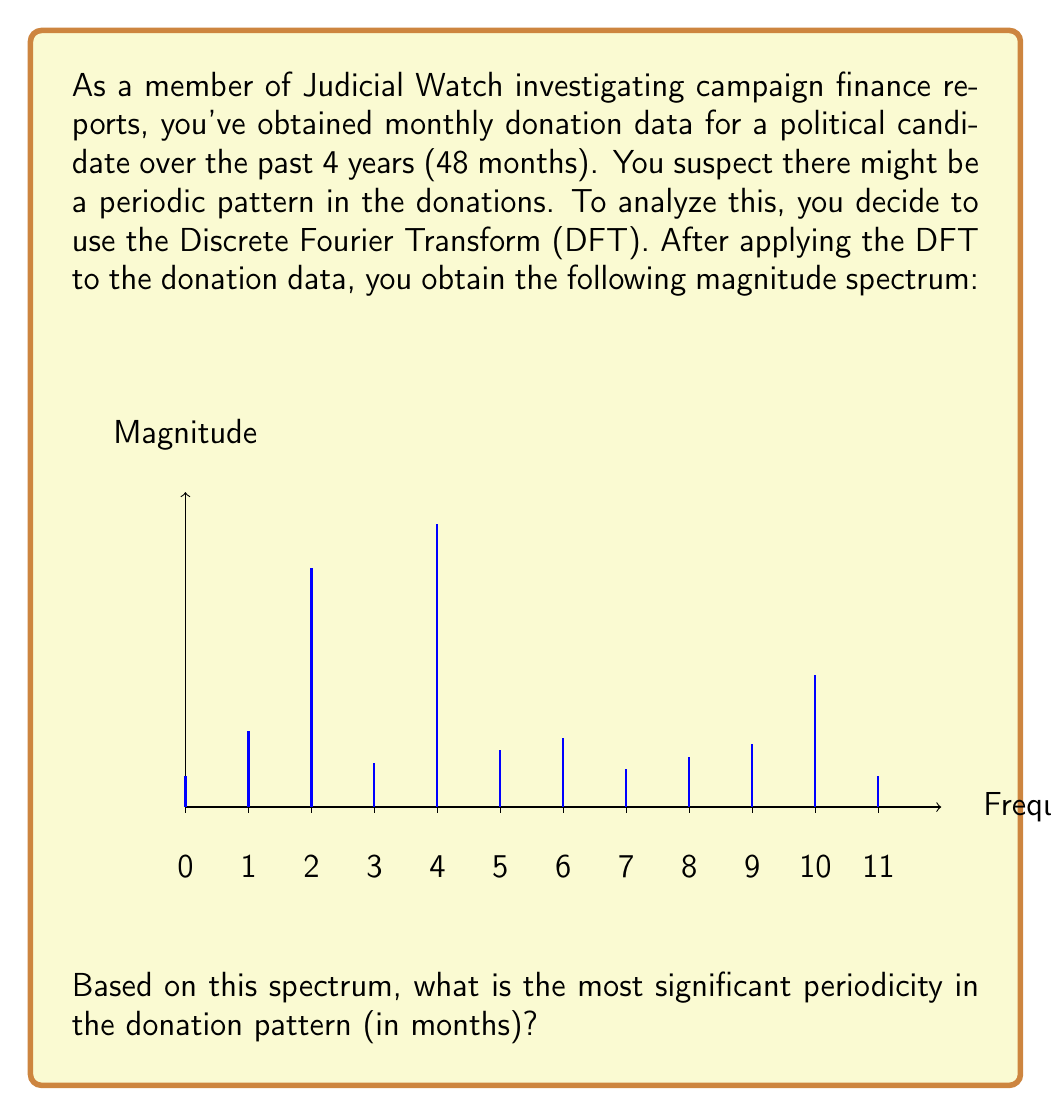Help me with this question. To determine the most significant periodicity from the DFT magnitude spectrum:

1) Recall that for N=48 monthly samples over 4 years, the frequency resolution is:
   $$\Delta f = \frac{f_s}{N} = \frac{12 \text{ samples/year}}{48 \text{ samples}} = 0.25 \text{ cycles/year}$$

2) Each index k in the spectrum represents a frequency of $k \cdot \Delta f$ cycles/year.

3) The magnitude spectrum shows the strength of each frequency component. The highest peak indicates the most significant periodic component.

4) From the graph, the highest peak is at index k=4, corresponding to:
   $$f = 4 \cdot 0.25 = 1 \text{ cycle/year}$$

5) To convert from cycles/year to period in months:
   $$T = \frac{1}{f} \cdot 12 \text{ months/year} = \frac{1}{1 \text{ cycle/year}} \cdot 12 \text{ months/year} = 12 \text{ months}$$

Therefore, the most significant periodicity in the donation pattern is 12 months, or 1 year.
Answer: 12 months 